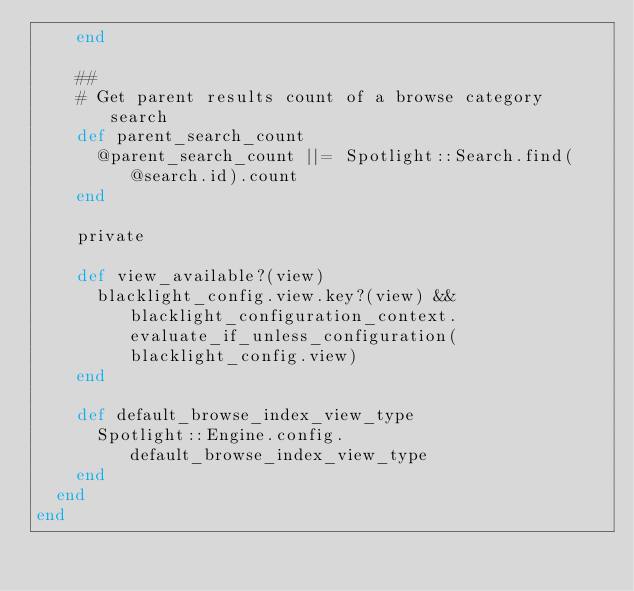Convert code to text. <code><loc_0><loc_0><loc_500><loc_500><_Ruby_>    end

    ##
    # Get parent results count of a browse category search
    def parent_search_count
      @parent_search_count ||= Spotlight::Search.find(@search.id).count
    end

    private

    def view_available?(view)
      blacklight_config.view.key?(view) && blacklight_configuration_context.evaluate_if_unless_configuration(blacklight_config.view)
    end

    def default_browse_index_view_type
      Spotlight::Engine.config.default_browse_index_view_type
    end
  end
end
</code> 